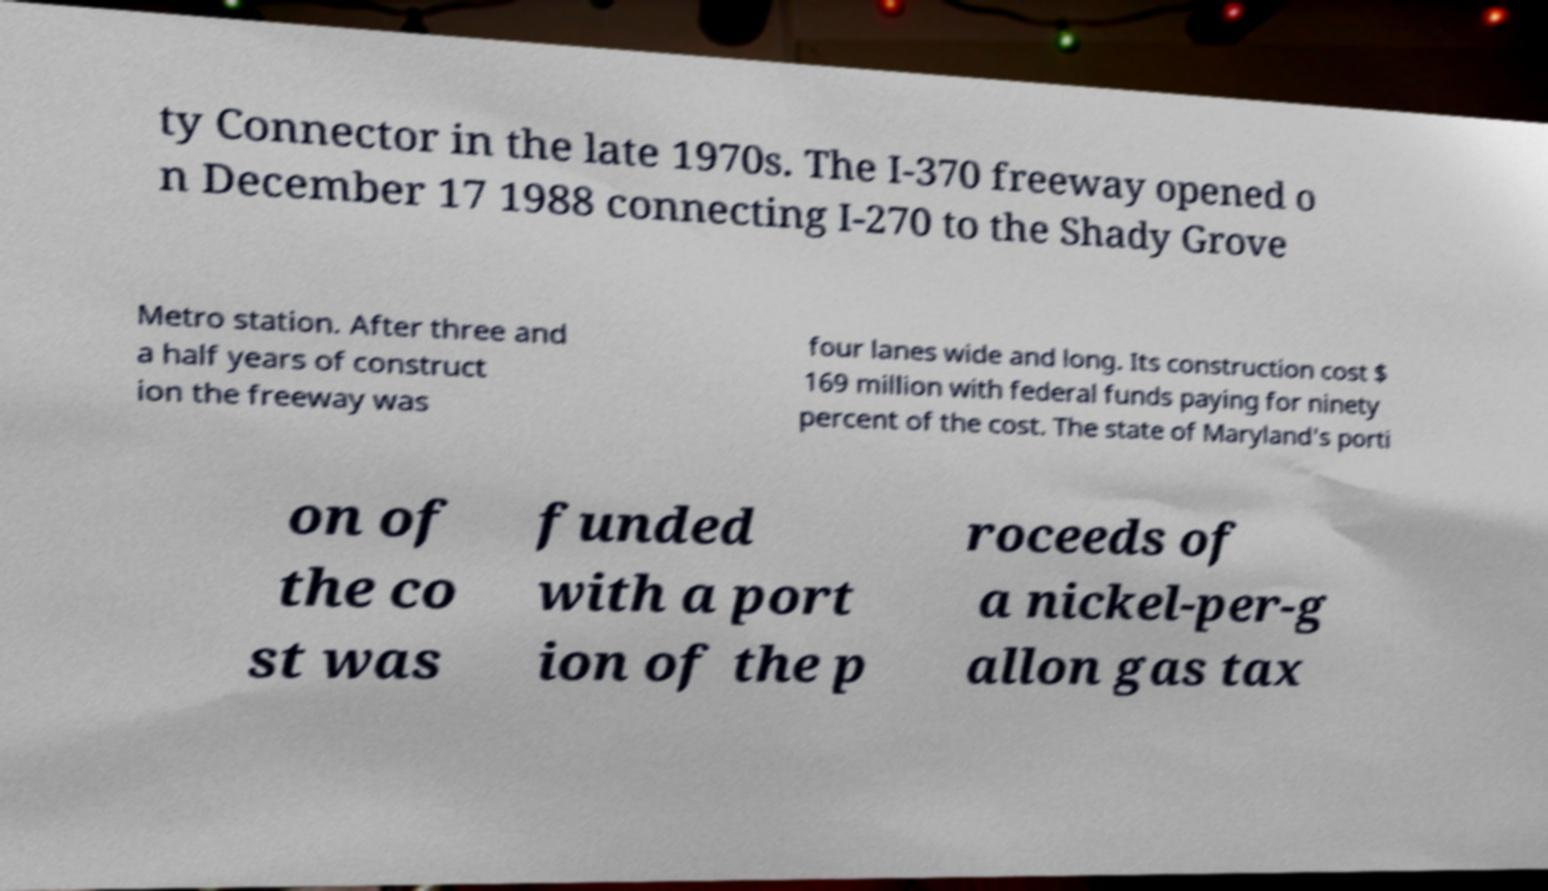Please identify and transcribe the text found in this image. ty Connector in the late 1970s. The I-370 freeway opened o n December 17 1988 connecting I-270 to the Shady Grove Metro station. After three and a half years of construct ion the freeway was four lanes wide and long. Its construction cost $ 169 million with federal funds paying for ninety percent of the cost. The state of Maryland's porti on of the co st was funded with a port ion of the p roceeds of a nickel-per-g allon gas tax 